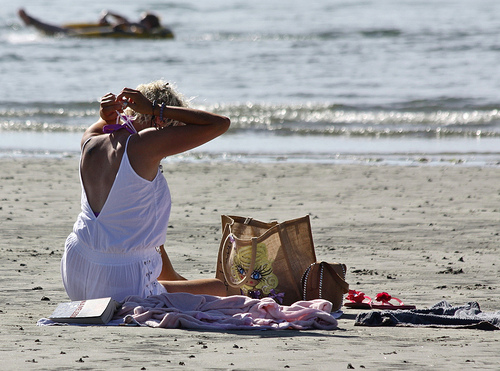<image>
Is the clothes on the person? No. The clothes is not positioned on the person. They may be near each other, but the clothes is not supported by or resting on top of the person. Is there a book next to the water? No. The book is not positioned next to the water. They are located in different areas of the scene. 